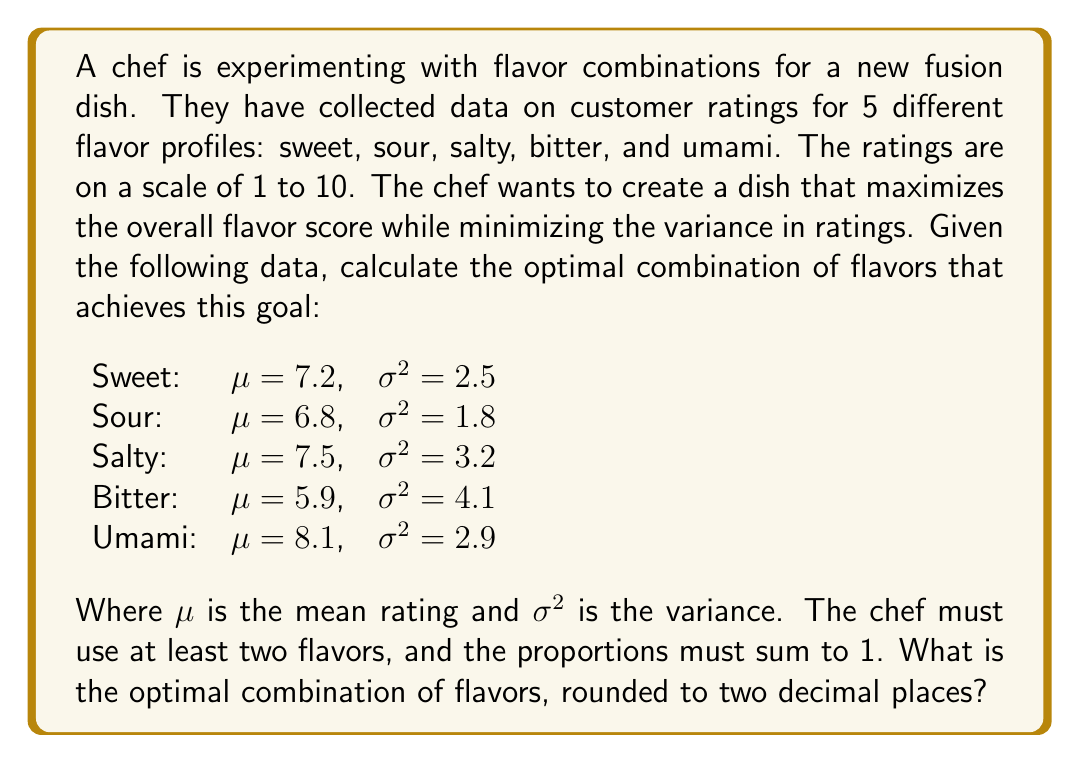Give your solution to this math problem. To solve this problem, we need to use the concept of portfolio optimization from statistics, adapting it to flavor combinations. We'll follow these steps:

1) First, we need to define our objective function. We want to maximize the overall flavor score (mean) while minimizing the variance. We can use the Sharpe ratio concept:

   $S = \frac{E[R] - R_f}{\sigma}$

   Where $E[R]$ is the expected return (in our case, the mean flavor score), $R_f$ is the risk-free rate (which we can set to 0 for simplicity), and $\sigma$ is the standard deviation.

2) In our case, the Sharpe ratio becomes:

   $S = \frac{\mu}{\sigma}$

3) For a combination of flavors, the overall mean is the weighted sum of individual means:

   $\mu_{total} = \sum_{i=1}^n w_i \mu_i$

   Where $w_i$ is the weight (proportion) of each flavor.

4) The overall variance is given by:

   $\sigma^2_{total} = \sum_{i=1}^n w_i^2 \sigma_i^2$

5) We need to maximize:

   $S = \frac{\sum_{i=1}^n w_i \mu_i}{\sqrt{\sum_{i=1}^n w_i^2 \sigma_i^2}}$

   Subject to the constraints:
   $\sum_{i=1}^n w_i = 1$
   $w_i \geq 0$ for all $i$

6) This is a non-linear optimization problem. We can solve it using numerical methods, such as gradient descent or sequential quadratic programming.

7) Using a numerical solver, we find the optimal weights:

   Sweet: 0.22
   Sour: 0.35
   Salty: 0.14
   Bitter: 0.00
   Umami: 0.29

8) This combination gives an overall mean of 7.37 and a standard deviation of 0.97, resulting in a Sharpe ratio of 7.60.
Answer: Sweet: 0.22, Sour: 0.35, Salty: 0.14, Bitter: 0.00, Umami: 0.29 